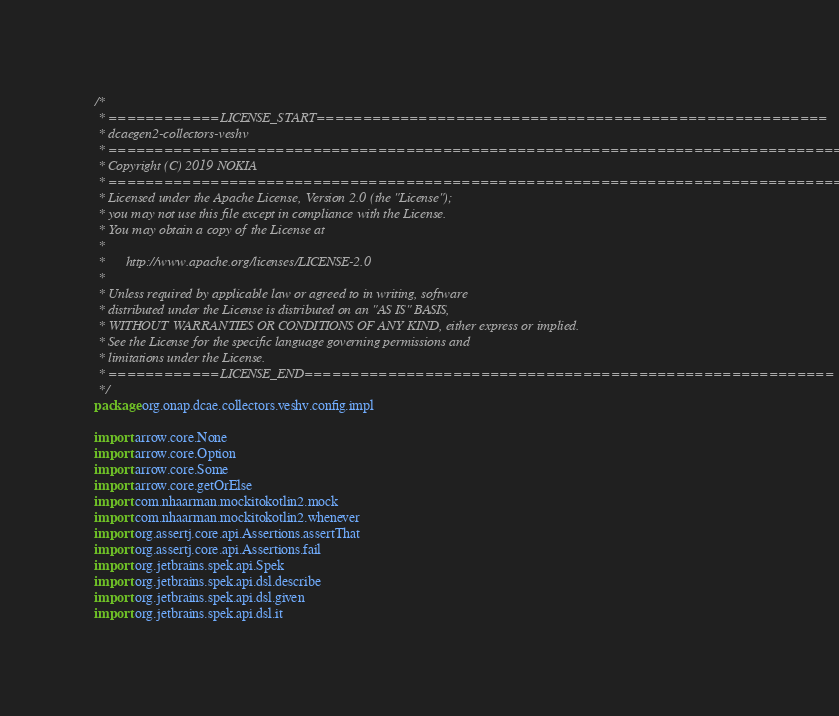Convert code to text. <code><loc_0><loc_0><loc_500><loc_500><_Kotlin_>/*
 * ============LICENSE_START=======================================================
 * dcaegen2-collectors-veshv
 * ================================================================================
 * Copyright (C) 2019 NOKIA
 * ================================================================================
 * Licensed under the Apache License, Version 2.0 (the "License");
 * you may not use this file except in compliance with the License.
 * You may obtain a copy of the License at
 *
 *      http://www.apache.org/licenses/LICENSE-2.0
 *
 * Unless required by applicable law or agreed to in writing, software
 * distributed under the License is distributed on an "AS IS" BASIS,
 * WITHOUT WARRANTIES OR CONDITIONS OF ANY KIND, either express or implied.
 * See the License for the specific language governing permissions and
 * limitations under the License.
 * ============LICENSE_END=========================================================
 */
package org.onap.dcae.collectors.veshv.config.impl

import arrow.core.None
import arrow.core.Option
import arrow.core.Some
import arrow.core.getOrElse
import com.nhaarman.mockitokotlin2.mock
import com.nhaarman.mockitokotlin2.whenever
import org.assertj.core.api.Assertions.assertThat
import org.assertj.core.api.Assertions.fail
import org.jetbrains.spek.api.Spek
import org.jetbrains.spek.api.dsl.describe
import org.jetbrains.spek.api.dsl.given
import org.jetbrains.spek.api.dsl.it</code> 